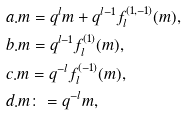Convert formula to latex. <formula><loc_0><loc_0><loc_500><loc_500>& a . m = q ^ { l } m + q ^ { l - 1 } f _ { l } ^ { ( 1 , - 1 ) } ( m ) , \\ & b . m = q ^ { l - 1 } f _ { l } ^ { ( 1 ) } ( m ) , \\ & c . m = q ^ { - l } f _ { l } ^ { ( - 1 ) } ( m ) , \\ & d . m \colon = q ^ { - l } m ,</formula> 